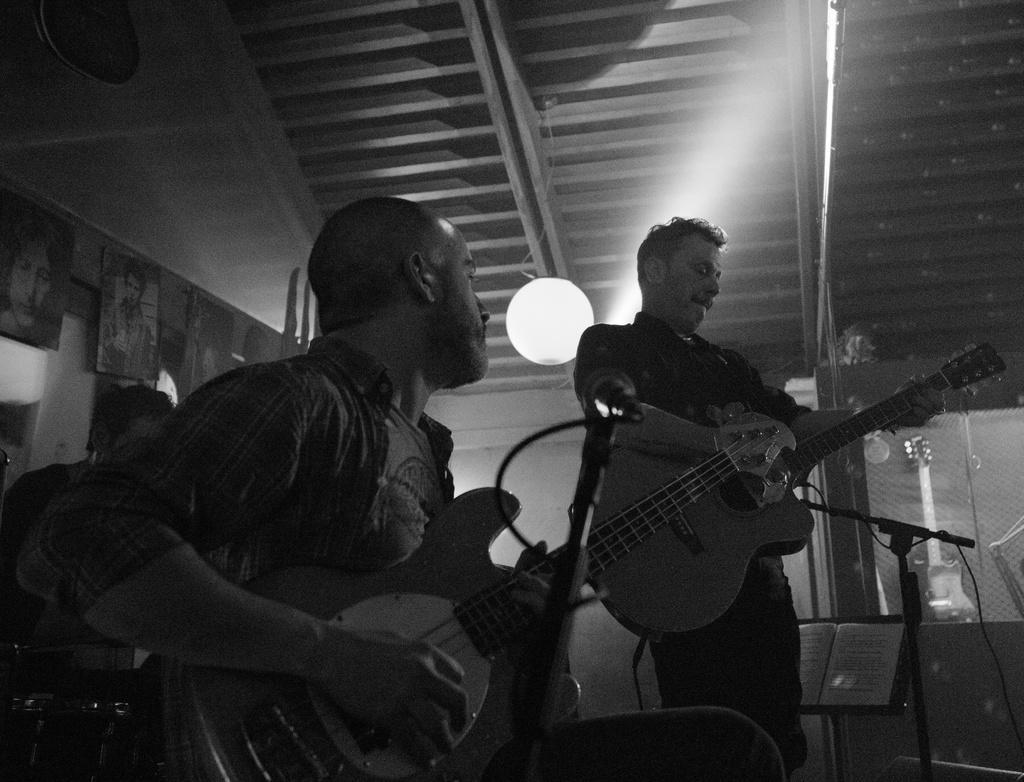Describe this image in one or two sentences. In this image i can see three man, the man sitting here is holding a guitar the man standing here is playing the guitar, at the back ground i can see a wall, at the top i can see a light and a shed. 